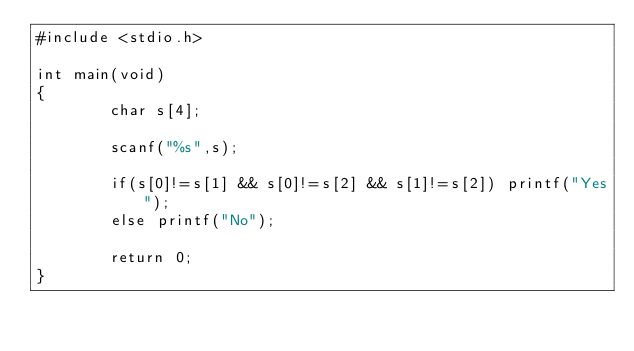<code> <loc_0><loc_0><loc_500><loc_500><_C_>#include <stdio.h>

int main(void)
{
        char s[4];

        scanf("%s",s);

        if(s[0]!=s[1] && s[0]!=s[2] && s[1]!=s[2]) printf("Yes");
        else printf("No");

        return 0;
}
</code> 